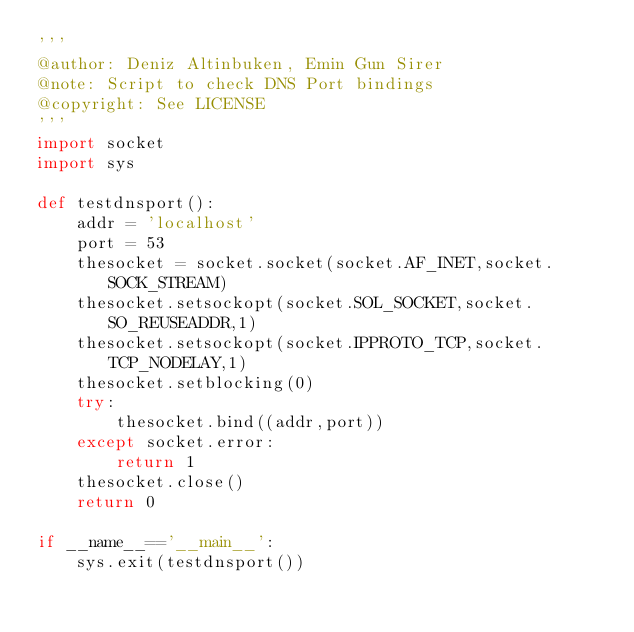Convert code to text. <code><loc_0><loc_0><loc_500><loc_500><_Python_>'''
@author: Deniz Altinbuken, Emin Gun Sirer
@note: Script to check DNS Port bindings
@copyright: See LICENSE
'''
import socket
import sys

def testdnsport():
    addr = 'localhost'
    port = 53
    thesocket = socket.socket(socket.AF_INET,socket.SOCK_STREAM)
    thesocket.setsockopt(socket.SOL_SOCKET,socket.SO_REUSEADDR,1)
    thesocket.setsockopt(socket.IPPROTO_TCP,socket.TCP_NODELAY,1)
    thesocket.setblocking(0)
    try:
        thesocket.bind((addr,port))
    except socket.error:
        return 1
    thesocket.close()
    return 0

if __name__=='__main__':
    sys.exit(testdnsport())
</code> 